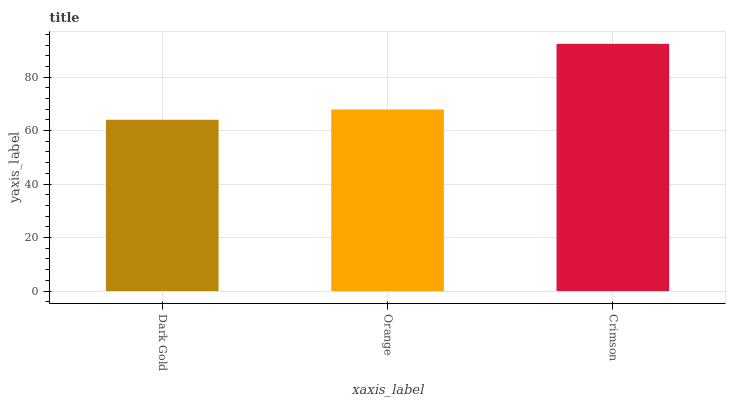Is Dark Gold the minimum?
Answer yes or no. Yes. Is Crimson the maximum?
Answer yes or no. Yes. Is Orange the minimum?
Answer yes or no. No. Is Orange the maximum?
Answer yes or no. No. Is Orange greater than Dark Gold?
Answer yes or no. Yes. Is Dark Gold less than Orange?
Answer yes or no. Yes. Is Dark Gold greater than Orange?
Answer yes or no. No. Is Orange less than Dark Gold?
Answer yes or no. No. Is Orange the high median?
Answer yes or no. Yes. Is Orange the low median?
Answer yes or no. Yes. Is Crimson the high median?
Answer yes or no. No. Is Crimson the low median?
Answer yes or no. No. 